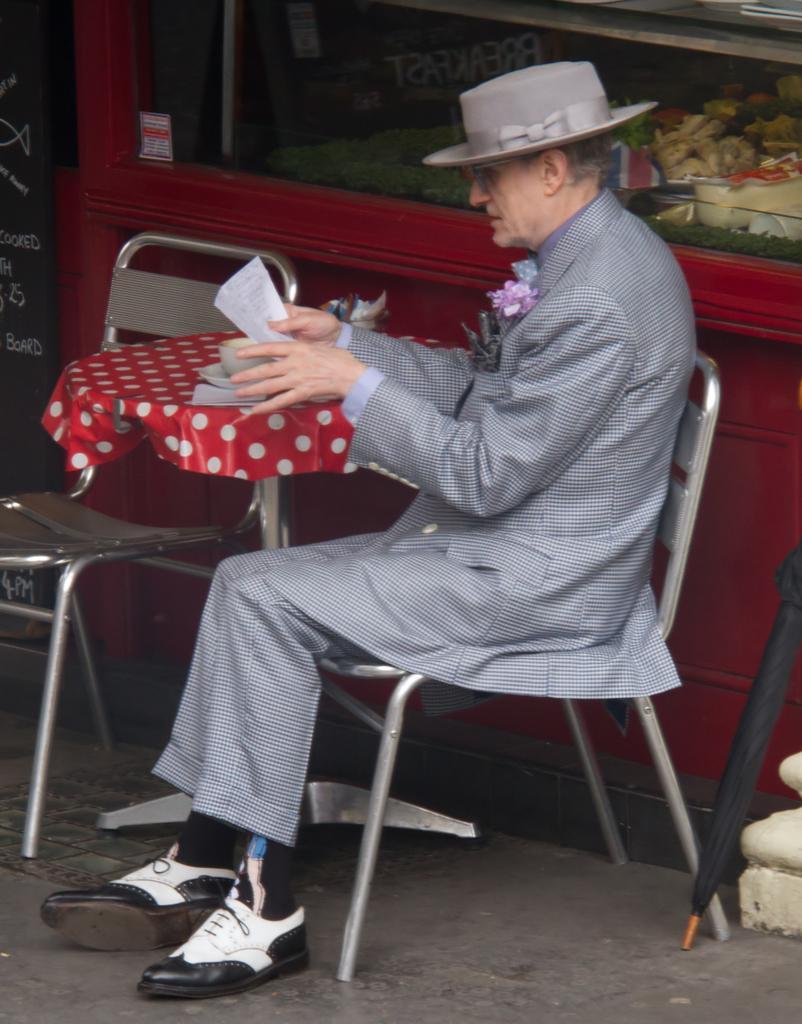Can you describe this image briefly? In this image I can see a man sitting on a chair. He is wearing a hat and holding a paper in his hand. I can also see one more chair and a table. Here I can see an umbrella. 